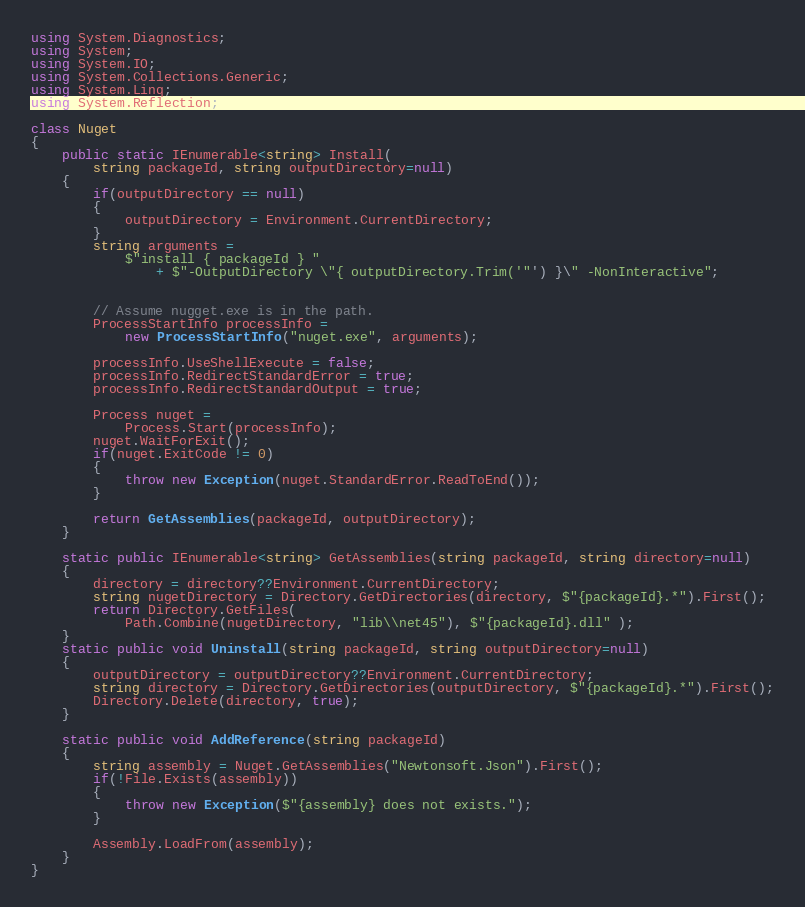<code> <loc_0><loc_0><loc_500><loc_500><_C#_>using System.Diagnostics;
using System;
using System.IO;
using System.Collections.Generic;
using System.Linq;
using System.Reflection;

class Nuget
{
	public static IEnumerable<string> Install(
		string packageId, string outputDirectory=null)
	{
		if(outputDirectory == null)
		{
			outputDirectory = Environment.CurrentDirectory;
		}
		string arguments = 
			$"install { packageId } " 
				+ $"-OutputDirectory \"{ outputDirectory.Trim('"') }\" -NonInteractive";
	

		// Assume nugget.exe is in the path.
		ProcessStartInfo processInfo = 
			new ProcessStartInfo("nuget.exe", arguments);
		
		processInfo.UseShellExecute = false;
		processInfo.RedirectStandardError = true;
		processInfo.RedirectStandardOutput = true;
			
		Process nuget = 
			Process.Start(processInfo);
		nuget.WaitForExit();
		if(nuget.ExitCode != 0)
		{
			throw new Exception(nuget.StandardError.ReadToEnd());
		}
		
		return GetAssemblies(packageId, outputDirectory);
	}
	
	static public IEnumerable<string> GetAssemblies(string packageId, string directory=null)
	{
		directory = directory??Environment.CurrentDirectory;
		string nugetDirectory = Directory.GetDirectories(directory, $"{packageId}.*").First();
		return Directory.GetFiles(
			Path.Combine(nugetDirectory, "lib\\net45"), $"{packageId}.dll" );
	}
	static public void Uninstall(string packageId, string outputDirectory=null)
	{
		outputDirectory = outputDirectory??Environment.CurrentDirectory;
		string directory = Directory.GetDirectories(outputDirectory, $"{packageId}.*").First();
		Directory.Delete(directory, true);		
	}
	
	static public void AddReference(string packageId)
	{
		string assembly = Nuget.GetAssemblies("Newtonsoft.Json").First();
		if(!File.Exists(assembly))
		{
			throw new Exception($"{assembly} does not exists.");
		}
		
		Assembly.LoadFrom(assembly);
	}
}

</code> 